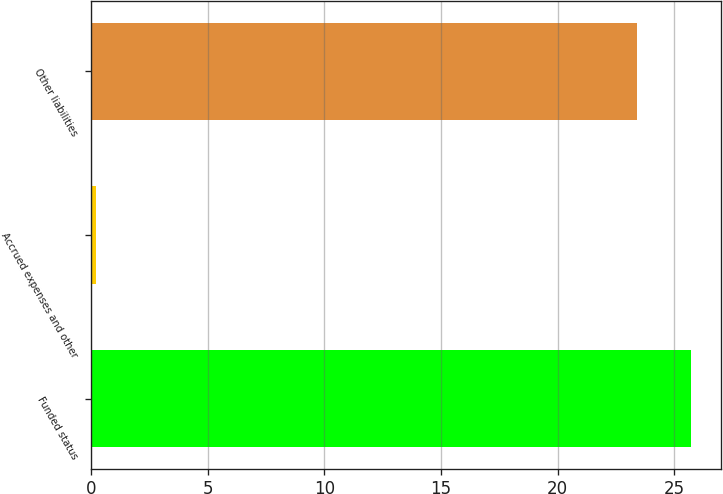<chart> <loc_0><loc_0><loc_500><loc_500><bar_chart><fcel>Funded status<fcel>Accrued expenses and other<fcel>Other liabilities<nl><fcel>25.74<fcel>0.2<fcel>23.4<nl></chart> 